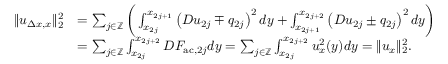Convert formula to latex. <formula><loc_0><loc_0><loc_500><loc_500>\begin{array} { r l } { \| u _ { \Delta x , x } \| _ { 2 } ^ { 2 } } & { = \sum _ { j \in \mathbb { Z } } \left ( \int _ { x _ { 2 j } } ^ { x _ { 2 j + 1 } } \left ( D u _ { 2 j } \mp q _ { 2 j } \right ) ^ { 2 } d y + \int _ { x _ { 2 j + 1 } } ^ { x _ { 2 j + 2 } } \left ( D u _ { 2 j } \pm q _ { 2 j } \right ) ^ { 2 } d y \right ) } \\ & { = \sum _ { j \in \mathbb { Z } } \int _ { x _ { 2 j } } ^ { x _ { 2 j + 2 } } D F _ { a c , 2 j } d y = \sum _ { j \in \mathbb { Z } } \int _ { x _ { 2 j } } ^ { x _ { 2 j + 2 } } u _ { x } ^ { 2 } ( y ) d y = \| u _ { x } \| _ { 2 } ^ { 2 } . } \end{array}</formula> 